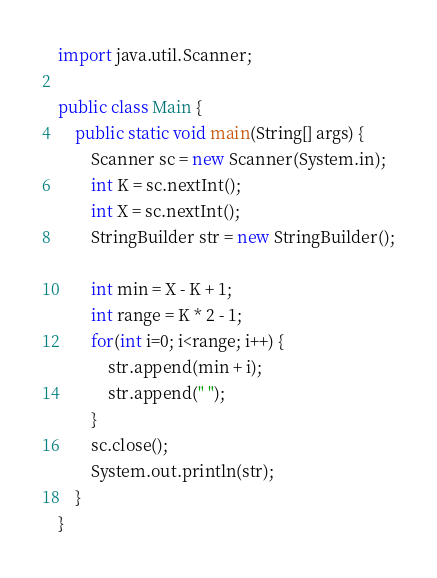<code> <loc_0><loc_0><loc_500><loc_500><_Java_>import java.util.Scanner;

public class Main {
	public static void main(String[] args) {
		Scanner sc = new Scanner(System.in);
		int K = sc.nextInt();
		int X = sc.nextInt();
		StringBuilder str = new StringBuilder();

		int min = X - K + 1;
		int range = K * 2 - 1;
		for(int i=0; i<range; i++) {
			str.append(min + i);
			str.append(" ");
		}
		sc.close();
		System.out.println(str);
	}
}</code> 